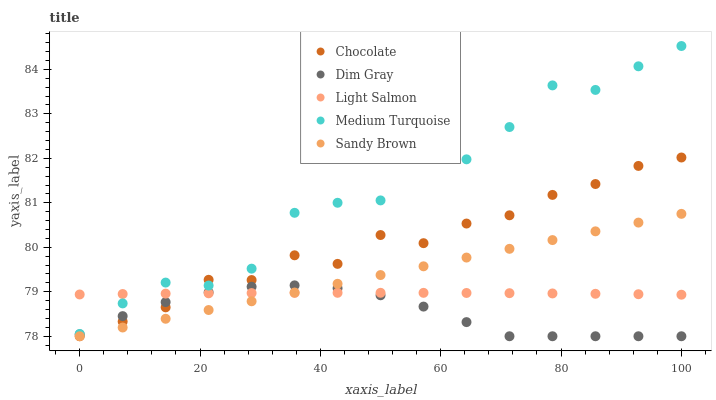Does Dim Gray have the minimum area under the curve?
Answer yes or no. Yes. Does Medium Turquoise have the maximum area under the curve?
Answer yes or no. Yes. Does Sandy Brown have the minimum area under the curve?
Answer yes or no. No. Does Sandy Brown have the maximum area under the curve?
Answer yes or no. No. Is Sandy Brown the smoothest?
Answer yes or no. Yes. Is Medium Turquoise the roughest?
Answer yes or no. Yes. Is Dim Gray the smoothest?
Answer yes or no. No. Is Dim Gray the roughest?
Answer yes or no. No. Does Dim Gray have the lowest value?
Answer yes or no. Yes. Does Medium Turquoise have the lowest value?
Answer yes or no. No. Does Medium Turquoise have the highest value?
Answer yes or no. Yes. Does Dim Gray have the highest value?
Answer yes or no. No. Is Dim Gray less than Medium Turquoise?
Answer yes or no. Yes. Is Medium Turquoise greater than Sandy Brown?
Answer yes or no. Yes. Does Chocolate intersect Light Salmon?
Answer yes or no. Yes. Is Chocolate less than Light Salmon?
Answer yes or no. No. Is Chocolate greater than Light Salmon?
Answer yes or no. No. Does Dim Gray intersect Medium Turquoise?
Answer yes or no. No. 